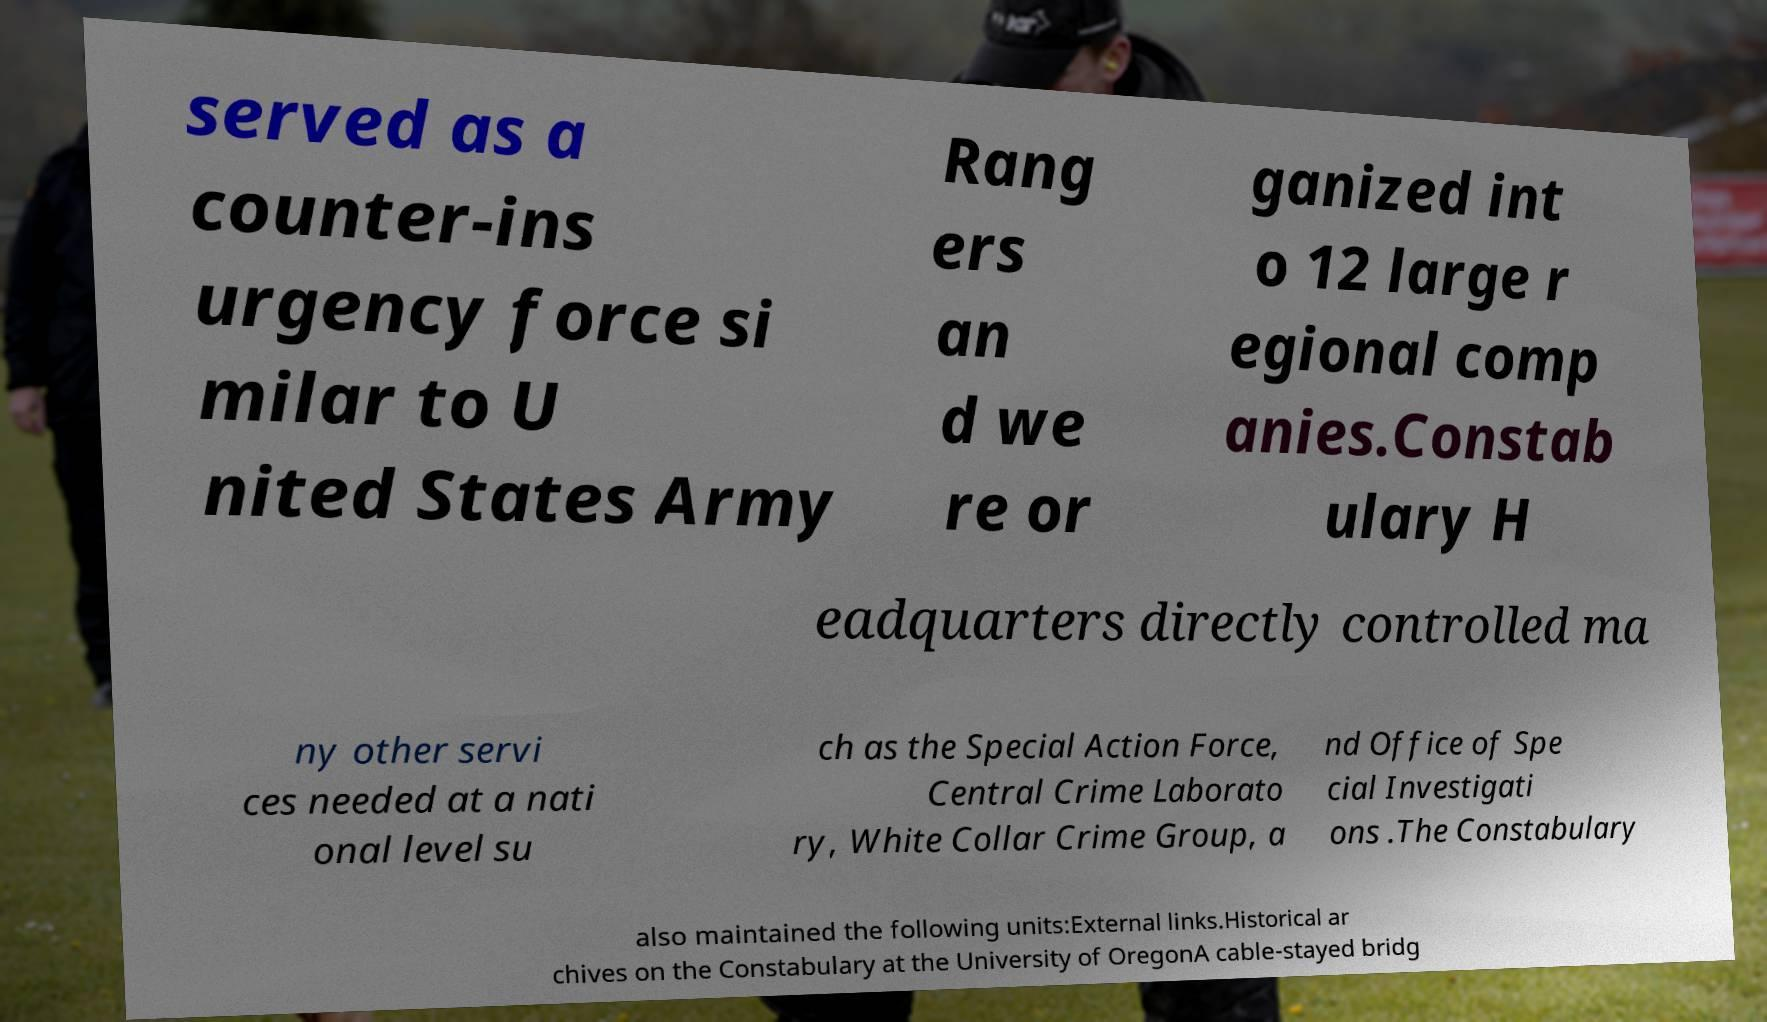Can you accurately transcribe the text from the provided image for me? served as a counter-ins urgency force si milar to U nited States Army Rang ers an d we re or ganized int o 12 large r egional comp anies.Constab ulary H eadquarters directly controlled ma ny other servi ces needed at a nati onal level su ch as the Special Action Force, Central Crime Laborato ry, White Collar Crime Group, a nd Office of Spe cial Investigati ons .The Constabulary also maintained the following units:External links.Historical ar chives on the Constabulary at the University of OregonA cable-stayed bridg 